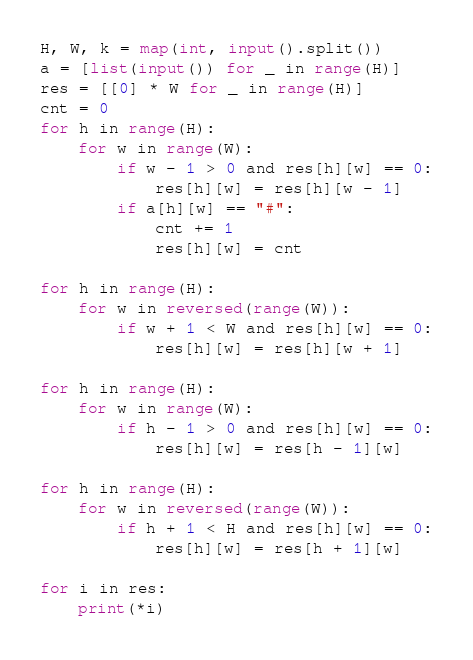Convert code to text. <code><loc_0><loc_0><loc_500><loc_500><_Python_>H, W, k = map(int, input().split())
a = [list(input()) for _ in range(H)]
res = [[0] * W for _ in range(H)]
cnt = 0
for h in range(H):
    for w in range(W):
        if w - 1 > 0 and res[h][w] == 0:
            res[h][w] = res[h][w - 1]
        if a[h][w] == "#":
            cnt += 1
            res[h][w] = cnt

for h in range(H):
    for w in reversed(range(W)):
        if w + 1 < W and res[h][w] == 0:
            res[h][w] = res[h][w + 1]

for h in range(H):
    for w in range(W):
        if h - 1 > 0 and res[h][w] == 0:
            res[h][w] = res[h - 1][w]

for h in range(H):
    for w in reversed(range(W)):
        if h + 1 < H and res[h][w] == 0:
            res[h][w] = res[h + 1][w]

for i in res:
    print(*i)
</code> 